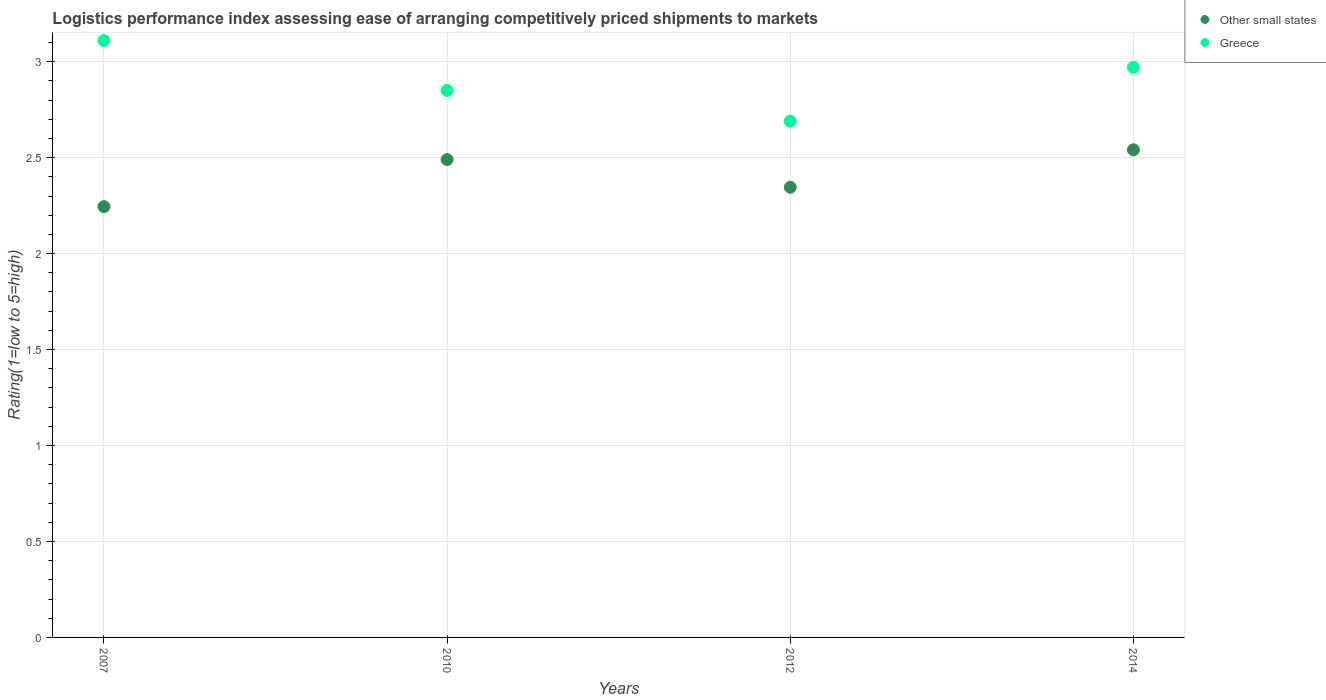What is the Logistic performance index in Greece in 2010?
Provide a short and direct response. 2.85. Across all years, what is the maximum Logistic performance index in Other small states?
Offer a terse response. 2.54. Across all years, what is the minimum Logistic performance index in Other small states?
Your answer should be compact. 2.24. In which year was the Logistic performance index in Other small states maximum?
Make the answer very short. 2014. What is the total Logistic performance index in Other small states in the graph?
Your answer should be compact. 9.62. What is the difference between the Logistic performance index in Other small states in 2010 and that in 2014?
Keep it short and to the point. -0.05. What is the difference between the Logistic performance index in Greece in 2010 and the Logistic performance index in Other small states in 2012?
Your answer should be compact. 0.5. What is the average Logistic performance index in Other small states per year?
Make the answer very short. 2.41. In the year 2012, what is the difference between the Logistic performance index in Greece and Logistic performance index in Other small states?
Provide a short and direct response. 0.34. What is the ratio of the Logistic performance index in Other small states in 2007 to that in 2012?
Provide a short and direct response. 0.96. What is the difference between the highest and the second highest Logistic performance index in Greece?
Ensure brevity in your answer.  0.14. What is the difference between the highest and the lowest Logistic performance index in Greece?
Give a very brief answer. 0.42. In how many years, is the Logistic performance index in Other small states greater than the average Logistic performance index in Other small states taken over all years?
Your response must be concise. 2. Is the sum of the Logistic performance index in Other small states in 2010 and 2012 greater than the maximum Logistic performance index in Greece across all years?
Keep it short and to the point. Yes. Is the Logistic performance index in Other small states strictly less than the Logistic performance index in Greece over the years?
Your answer should be very brief. Yes. How many dotlines are there?
Ensure brevity in your answer.  2. Are the values on the major ticks of Y-axis written in scientific E-notation?
Offer a very short reply. No. Does the graph contain grids?
Your answer should be compact. Yes. Where does the legend appear in the graph?
Provide a short and direct response. Top right. How many legend labels are there?
Offer a terse response. 2. How are the legend labels stacked?
Offer a terse response. Vertical. What is the title of the graph?
Make the answer very short. Logistics performance index assessing ease of arranging competitively priced shipments to markets. What is the label or title of the Y-axis?
Provide a short and direct response. Rating(1=low to 5=high). What is the Rating(1=low to 5=high) of Other small states in 2007?
Offer a very short reply. 2.24. What is the Rating(1=low to 5=high) in Greece in 2007?
Make the answer very short. 3.11. What is the Rating(1=low to 5=high) of Other small states in 2010?
Provide a succinct answer. 2.49. What is the Rating(1=low to 5=high) in Greece in 2010?
Keep it short and to the point. 2.85. What is the Rating(1=low to 5=high) of Other small states in 2012?
Your response must be concise. 2.35. What is the Rating(1=low to 5=high) in Greece in 2012?
Your response must be concise. 2.69. What is the Rating(1=low to 5=high) in Other small states in 2014?
Offer a terse response. 2.54. What is the Rating(1=low to 5=high) in Greece in 2014?
Give a very brief answer. 2.97. Across all years, what is the maximum Rating(1=low to 5=high) of Other small states?
Give a very brief answer. 2.54. Across all years, what is the maximum Rating(1=low to 5=high) of Greece?
Keep it short and to the point. 3.11. Across all years, what is the minimum Rating(1=low to 5=high) of Other small states?
Give a very brief answer. 2.24. Across all years, what is the minimum Rating(1=low to 5=high) in Greece?
Your answer should be very brief. 2.69. What is the total Rating(1=low to 5=high) in Other small states in the graph?
Give a very brief answer. 9.62. What is the total Rating(1=low to 5=high) of Greece in the graph?
Give a very brief answer. 11.62. What is the difference between the Rating(1=low to 5=high) of Other small states in 2007 and that in 2010?
Offer a very short reply. -0.25. What is the difference between the Rating(1=low to 5=high) of Greece in 2007 and that in 2010?
Keep it short and to the point. 0.26. What is the difference between the Rating(1=low to 5=high) of Other small states in 2007 and that in 2012?
Offer a terse response. -0.1. What is the difference between the Rating(1=low to 5=high) of Greece in 2007 and that in 2012?
Offer a very short reply. 0.42. What is the difference between the Rating(1=low to 5=high) in Other small states in 2007 and that in 2014?
Provide a succinct answer. -0.3. What is the difference between the Rating(1=low to 5=high) in Greece in 2007 and that in 2014?
Your response must be concise. 0.14. What is the difference between the Rating(1=low to 5=high) of Other small states in 2010 and that in 2012?
Your answer should be very brief. 0.14. What is the difference between the Rating(1=low to 5=high) in Greece in 2010 and that in 2012?
Keep it short and to the point. 0.16. What is the difference between the Rating(1=low to 5=high) in Other small states in 2010 and that in 2014?
Keep it short and to the point. -0.05. What is the difference between the Rating(1=low to 5=high) of Greece in 2010 and that in 2014?
Offer a terse response. -0.12. What is the difference between the Rating(1=low to 5=high) in Other small states in 2012 and that in 2014?
Your response must be concise. -0.2. What is the difference between the Rating(1=low to 5=high) in Greece in 2012 and that in 2014?
Keep it short and to the point. -0.28. What is the difference between the Rating(1=low to 5=high) in Other small states in 2007 and the Rating(1=low to 5=high) in Greece in 2010?
Provide a succinct answer. -0.61. What is the difference between the Rating(1=low to 5=high) in Other small states in 2007 and the Rating(1=low to 5=high) in Greece in 2012?
Offer a terse response. -0.45. What is the difference between the Rating(1=low to 5=high) in Other small states in 2007 and the Rating(1=low to 5=high) in Greece in 2014?
Provide a succinct answer. -0.73. What is the difference between the Rating(1=low to 5=high) of Other small states in 2010 and the Rating(1=low to 5=high) of Greece in 2014?
Provide a succinct answer. -0.48. What is the difference between the Rating(1=low to 5=high) of Other small states in 2012 and the Rating(1=low to 5=high) of Greece in 2014?
Provide a short and direct response. -0.62. What is the average Rating(1=low to 5=high) of Other small states per year?
Your answer should be very brief. 2.41. What is the average Rating(1=low to 5=high) of Greece per year?
Keep it short and to the point. 2.91. In the year 2007, what is the difference between the Rating(1=low to 5=high) of Other small states and Rating(1=low to 5=high) of Greece?
Your response must be concise. -0.87. In the year 2010, what is the difference between the Rating(1=low to 5=high) in Other small states and Rating(1=low to 5=high) in Greece?
Make the answer very short. -0.36. In the year 2012, what is the difference between the Rating(1=low to 5=high) of Other small states and Rating(1=low to 5=high) of Greece?
Provide a short and direct response. -0.34. In the year 2014, what is the difference between the Rating(1=low to 5=high) in Other small states and Rating(1=low to 5=high) in Greece?
Offer a very short reply. -0.43. What is the ratio of the Rating(1=low to 5=high) of Other small states in 2007 to that in 2010?
Provide a short and direct response. 0.9. What is the ratio of the Rating(1=low to 5=high) of Greece in 2007 to that in 2010?
Ensure brevity in your answer.  1.09. What is the ratio of the Rating(1=low to 5=high) of Greece in 2007 to that in 2012?
Keep it short and to the point. 1.16. What is the ratio of the Rating(1=low to 5=high) in Other small states in 2007 to that in 2014?
Keep it short and to the point. 0.88. What is the ratio of the Rating(1=low to 5=high) of Greece in 2007 to that in 2014?
Your answer should be very brief. 1.05. What is the ratio of the Rating(1=low to 5=high) of Other small states in 2010 to that in 2012?
Provide a succinct answer. 1.06. What is the ratio of the Rating(1=low to 5=high) in Greece in 2010 to that in 2012?
Provide a short and direct response. 1.06. What is the ratio of the Rating(1=low to 5=high) of Other small states in 2010 to that in 2014?
Your response must be concise. 0.98. What is the ratio of the Rating(1=low to 5=high) in Greece in 2010 to that in 2014?
Provide a short and direct response. 0.96. What is the ratio of the Rating(1=low to 5=high) of Other small states in 2012 to that in 2014?
Provide a succinct answer. 0.92. What is the ratio of the Rating(1=low to 5=high) in Greece in 2012 to that in 2014?
Offer a very short reply. 0.91. What is the difference between the highest and the second highest Rating(1=low to 5=high) of Other small states?
Offer a very short reply. 0.05. What is the difference between the highest and the second highest Rating(1=low to 5=high) of Greece?
Make the answer very short. 0.14. What is the difference between the highest and the lowest Rating(1=low to 5=high) in Other small states?
Your answer should be very brief. 0.3. What is the difference between the highest and the lowest Rating(1=low to 5=high) in Greece?
Offer a very short reply. 0.42. 